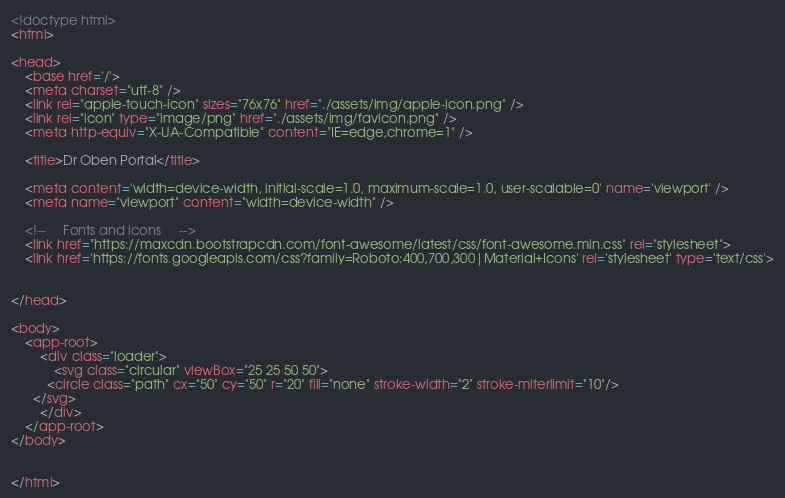<code> <loc_0><loc_0><loc_500><loc_500><_HTML_><!doctype html>
<html>

<head>
    <base href='/'>
    <meta charset="utf-8" />
    <link rel="apple-touch-icon" sizes="76x76" href="./assets/img/apple-icon.png" />
    <link rel="icon" type="image/png" href="./assets/img/favicon.png" />
    <meta http-equiv="X-UA-Compatible" content="IE=edge,chrome=1" />

    <title>Dr Oben Portal</title>

    <meta content='width=device-width, initial-scale=1.0, maximum-scale=1.0, user-scalable=0' name='viewport' />
    <meta name="viewport" content="width=device-width" />

    <!--     Fonts and icons     -->
    <link href="https://maxcdn.bootstrapcdn.com/font-awesome/latest/css/font-awesome.min.css" rel="stylesheet">
    <link href='https://fonts.googleapis.com/css?family=Roboto:400,700,300|Material+Icons' rel='stylesheet' type='text/css'>


</head>

<body>
    <app-root>
        <div class="loader">
            <svg class="circular" viewBox="25 25 50 50">
          <circle class="path" cx="50" cy="50" r="20" fill="none" stroke-width="2" stroke-miterlimit="10"/>
      </svg>
        </div>
    </app-root>
</body>


</html></code> 